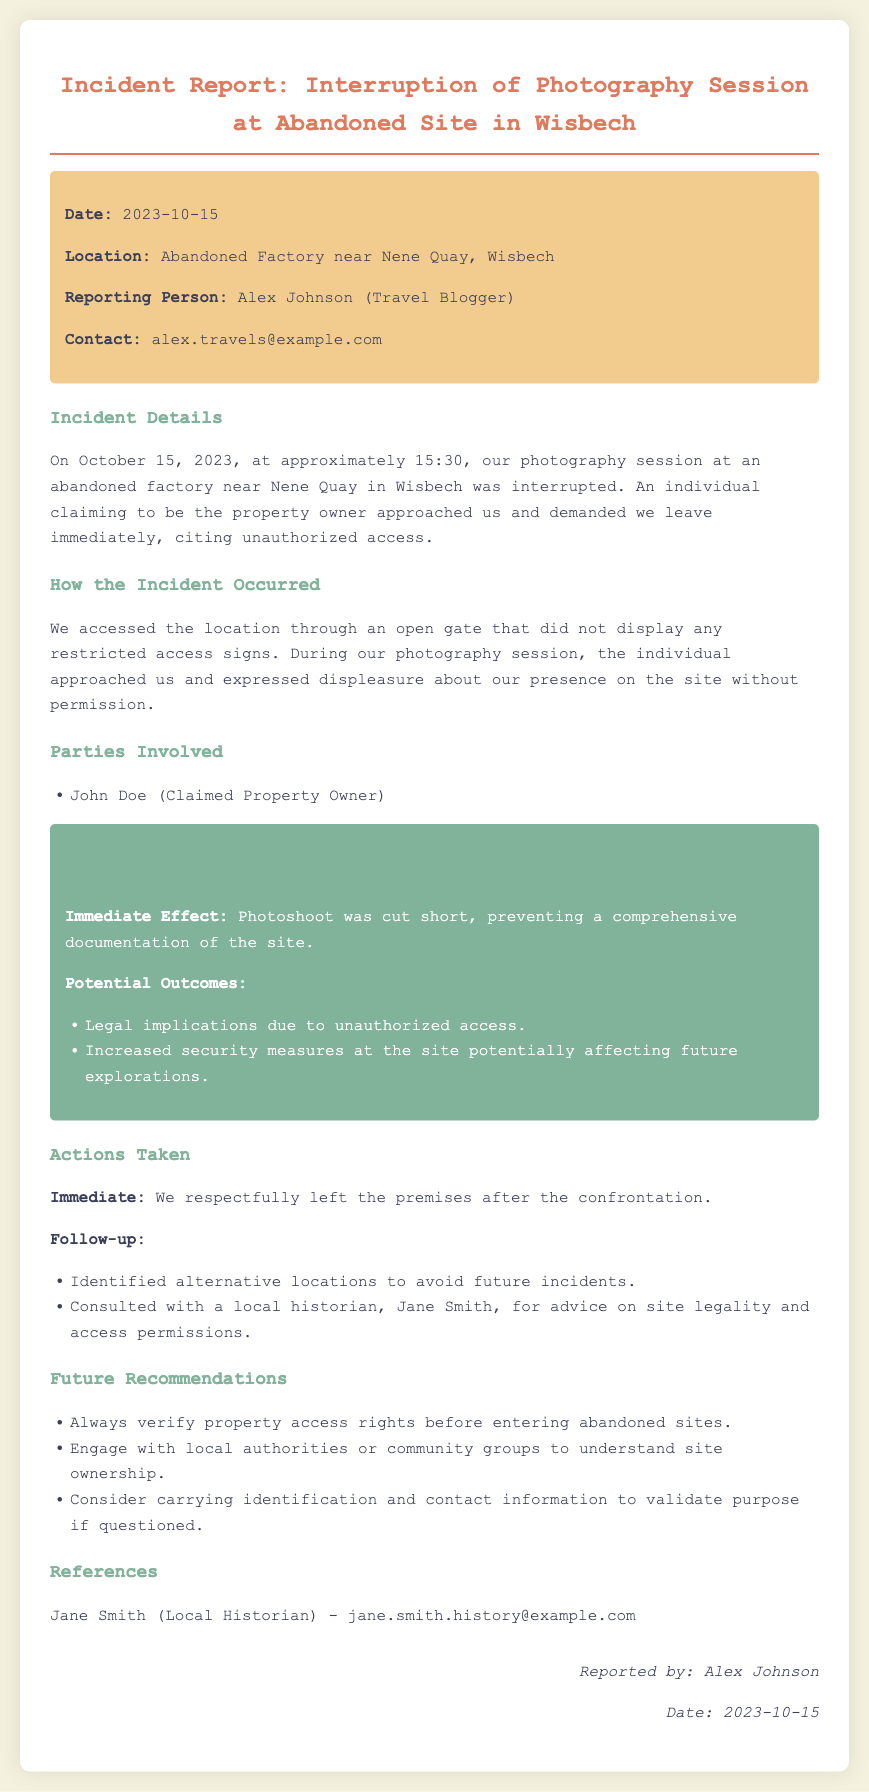What date did the incident occur? The incident date is explicitly stated in the document.
Answer: 2023-10-15 Where did the interruption of the photography session take place? The location of the incident is mentioned in the report.
Answer: Abandoned Factory near Nene Quay, Wisbech Who reported the incident? The reporting person's name is provided in the document.
Answer: Alex Johnson What was the immediate effect of the incident? The impact section describes the immediate effect on the photography session.
Answer: Photoshoot was cut short Who did the individual claiming to be the property owner approach? The party involved in the incident is listed in the document.
Answer: Us What is one potential outcome mentioned regarding the incident? The report outlines potential outcomes in the impact section.
Answer: Legal implications due to unauthorized access What action was taken immediately following the confrontation? The actions taken after the incident are described in the report.
Answer: We respectfully left the premises Who was consulted for advice on site legality? The follow-up actions include a consultation mentioned in the report.
Answer: Jane Smith 